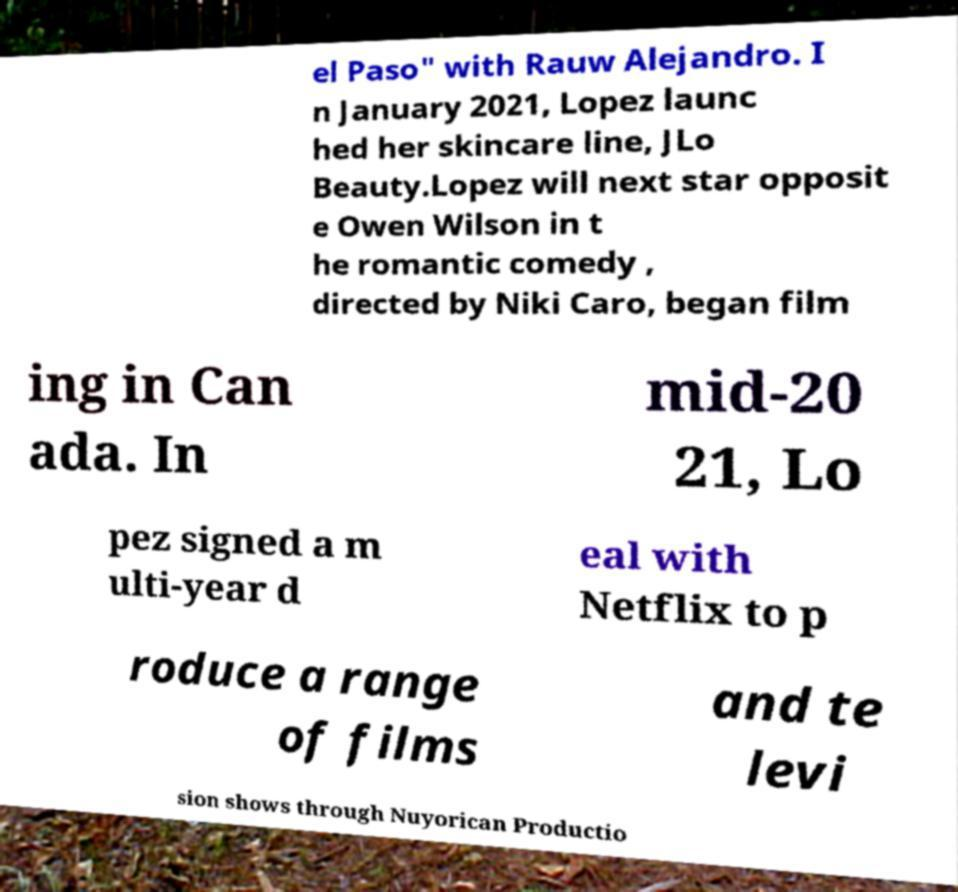There's text embedded in this image that I need extracted. Can you transcribe it verbatim? el Paso" with Rauw Alejandro. I n January 2021, Lopez launc hed her skincare line, JLo Beauty.Lopez will next star opposit e Owen Wilson in t he romantic comedy , directed by Niki Caro, began film ing in Can ada. In mid-20 21, Lo pez signed a m ulti-year d eal with Netflix to p roduce a range of films and te levi sion shows through Nuyorican Productio 